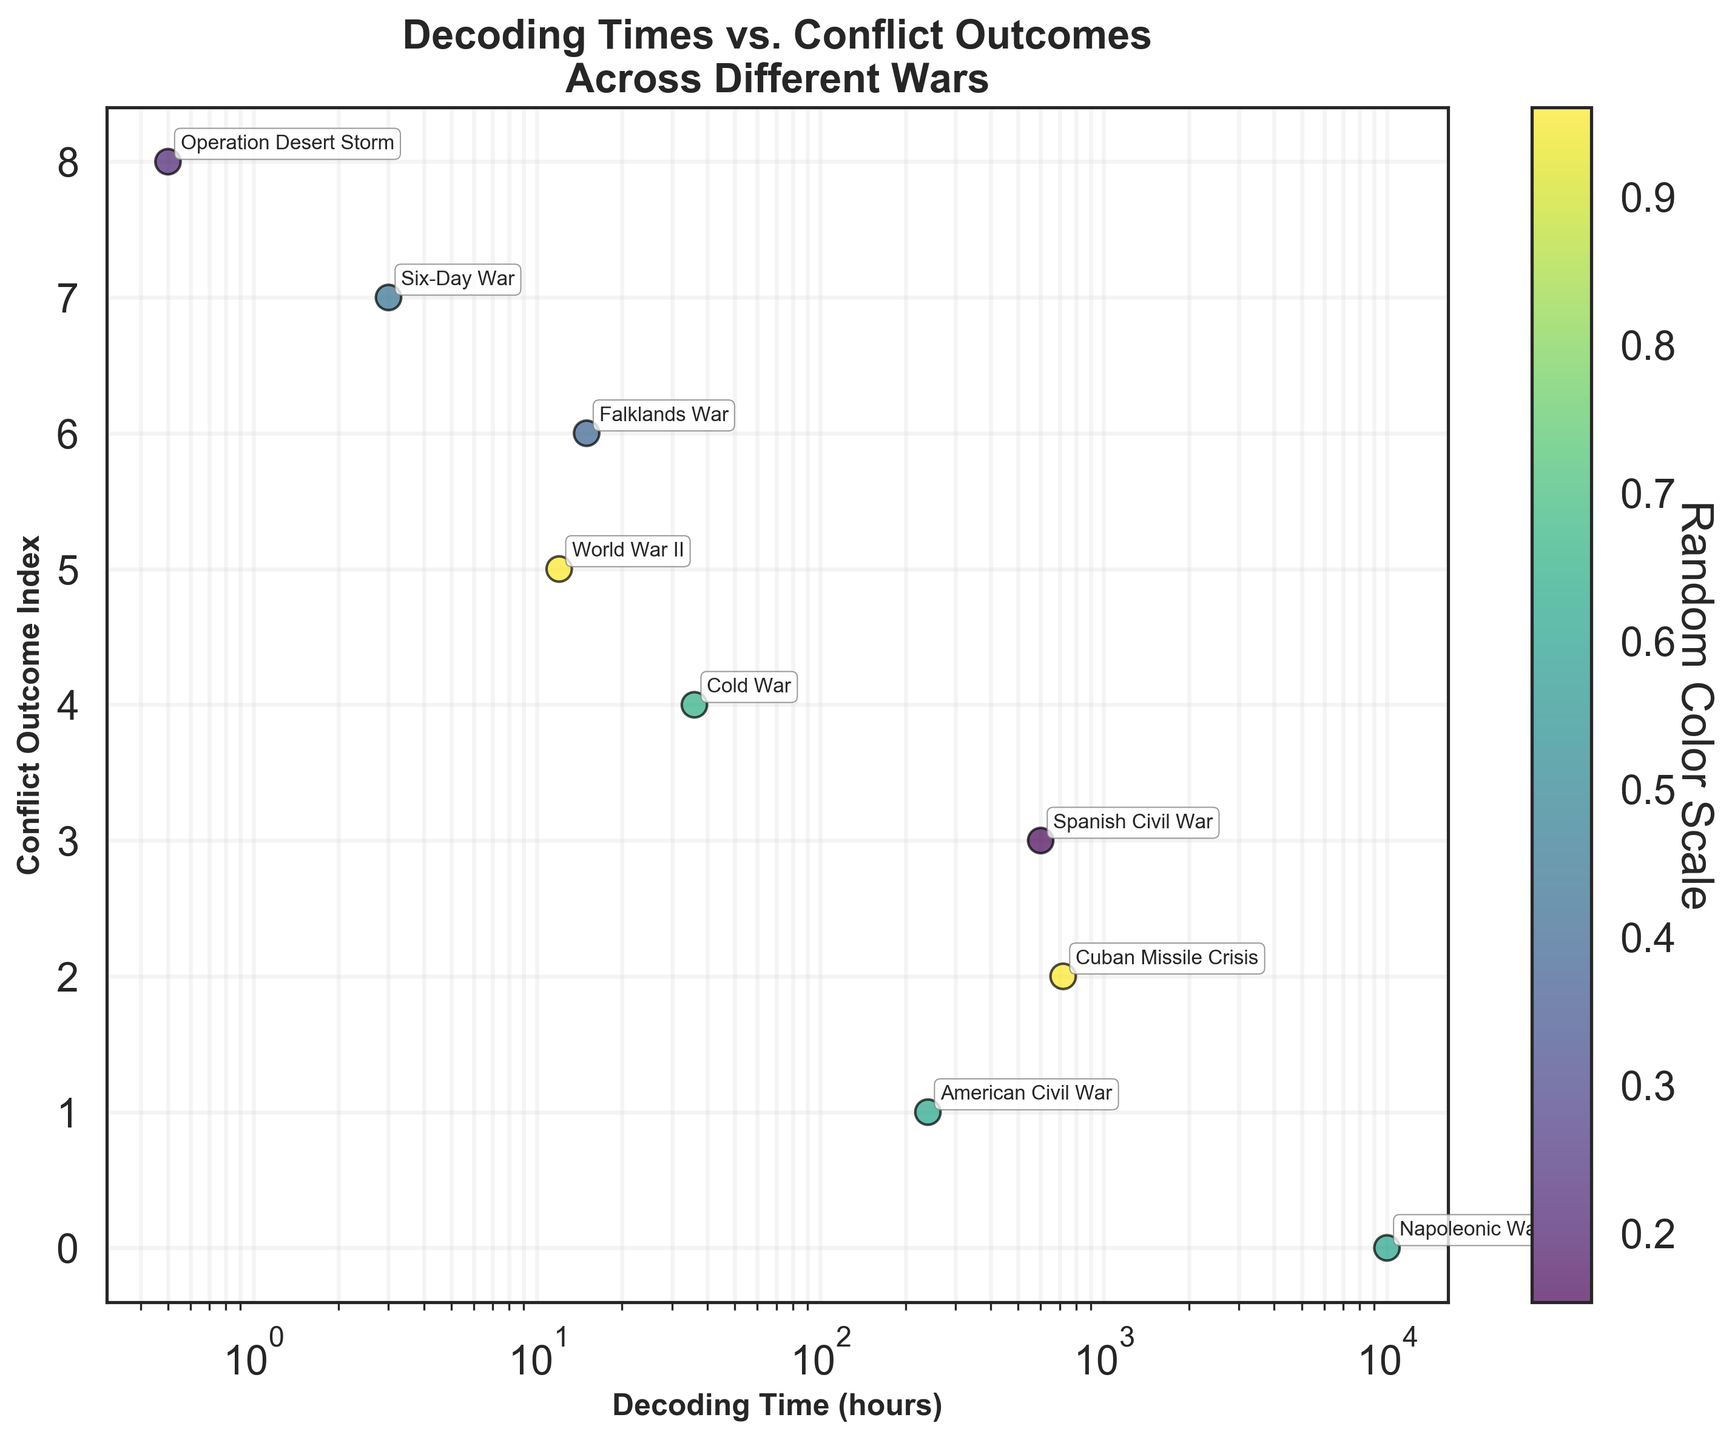what is the title of the figure? The title is located at the top of the figure and provides a brief description of what the figure is about.
Answer: Decoding Times vs. Conflict Outcomes Across Different Wars How many wars are represented in the figure? The number of wars can be determined by counting the distinct data points (scatter points) on the figure.
Answer: 9 Which war had the shortest decoding time? The shortest decoding time can be found by identifying the point on the leftmost side of the x-axis (log scale), which corresponds to the lowest decoding time.
Answer: Operation Desert Storm Which war had the highest conflict outcome index? The highest conflict outcome index is represented by the point at the highest position along the y-axis.
Answer: Operation Desert Storm What is the decoding time for the Falklands War? Look for the point labeled "Falklands War" and read off its value on the x-axis.
Answer: 15 hours Which wars have a decoding time greater than 1000 hours? Identify points to the right of the x-axis marking 1000 hours.
Answer: Napoleonic Wars, Cuban Missile Crisis Compare the conflict outcome index of the Cold War and Spanish Civil War. Which one is higher? Find the points labeled "Cold War" and "Spanish Civil War" and compare their positions on the y-axis. The higher position indicates a higher conflict outcome index.
Answer: Cold War What is the average decoding time across all wars? Add up all the decoding times and divide by the total number of wars: (12 + 240 + 36 + 10000 + 0.5 + 720 + 15 + 600 + 3) / 9.
Answer: 1247.5 hours How does the conflict outcome index of the Six-Day War compare to that of World War II? Find the points labeled "Six-Day War" and "World War II" and compare their positions on the y-axis to determine which is higher.
Answer: Six-Day War is higher What is the relationship between decoding time and conflict outcomes? By examining the overall trend in the scatter plot, determine whether there is an increasing, decreasing, or no clear pattern between decoding time and conflict outcome index.
Answer: No clear pattern 